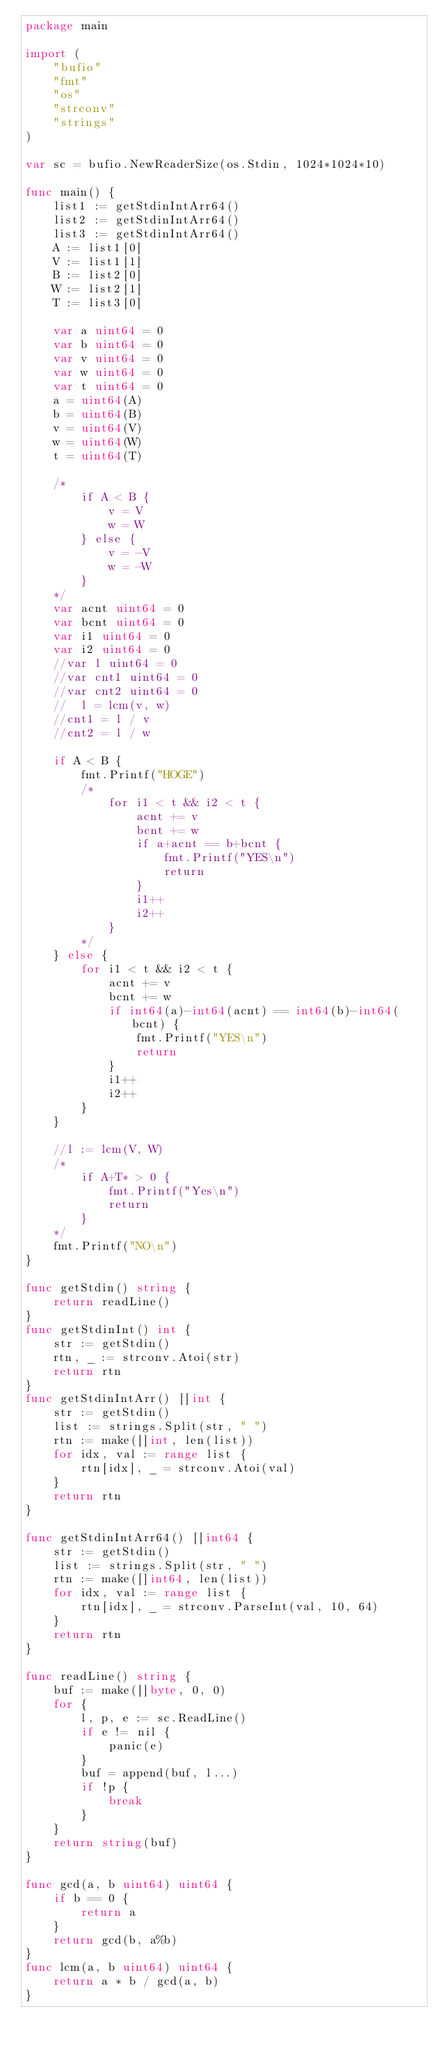Convert code to text. <code><loc_0><loc_0><loc_500><loc_500><_Go_>package main

import (
	"bufio"
	"fmt"
	"os"
	"strconv"
	"strings"
)

var sc = bufio.NewReaderSize(os.Stdin, 1024*1024*10)

func main() {
	list1 := getStdinIntArr64()
	list2 := getStdinIntArr64()
	list3 := getStdinIntArr64()
	A := list1[0]
	V := list1[1]
	B := list2[0]
	W := list2[1]
	T := list3[0]

	var a uint64 = 0
	var b uint64 = 0
	var v uint64 = 0
	var w uint64 = 0
	var t uint64 = 0
	a = uint64(A)
	b = uint64(B)
	v = uint64(V)
	w = uint64(W)
	t = uint64(T)

	/*
		if A < B {
			v = V
			w = W
		} else {
			v = -V
			w = -W
		}
	*/
	var acnt uint64 = 0
	var bcnt uint64 = 0
	var i1 uint64 = 0
	var i2 uint64 = 0
	//var l uint64 = 0
	//var cnt1 uint64 = 0
	//var cnt2 uint64 = 0
	//	l = lcm(v, w)
	//cnt1 = l / v
	//cnt2 = l / w

	if A < B {
		fmt.Printf("HOGE")
		/*
			for i1 < t && i2 < t {
				acnt += v
				bcnt += w
				if a+acnt == b+bcnt {
					fmt.Printf("YES\n")
					return
				}
				i1++
				i2++
			}
		*/
	} else {
		for i1 < t && i2 < t {
			acnt += v
			bcnt += w
			if int64(a)-int64(acnt) == int64(b)-int64(bcnt) {
				fmt.Printf("YES\n")
				return
			}
			i1++
			i2++
		}
	}

	//l := lcm(V, W)
	/*
		if A+T* > 0 {
			fmt.Printf("Yes\n")
			return
		}
	*/
	fmt.Printf("NO\n")
}

func getStdin() string {
	return readLine()
}
func getStdinInt() int {
	str := getStdin()
	rtn, _ := strconv.Atoi(str)
	return rtn
}
func getStdinIntArr() []int {
	str := getStdin()
	list := strings.Split(str, " ")
	rtn := make([]int, len(list))
	for idx, val := range list {
		rtn[idx], _ = strconv.Atoi(val)
	}
	return rtn
}

func getStdinIntArr64() []int64 {
	str := getStdin()
	list := strings.Split(str, " ")
	rtn := make([]int64, len(list))
	for idx, val := range list {
		rtn[idx], _ = strconv.ParseInt(val, 10, 64)
	}
	return rtn
}

func readLine() string {
	buf := make([]byte, 0, 0)
	for {
		l, p, e := sc.ReadLine()
		if e != nil {
			panic(e)
		}
		buf = append(buf, l...)
		if !p {
			break
		}
	}
	return string(buf)
}

func gcd(a, b uint64) uint64 {
	if b == 0 {
		return a
	}
	return gcd(b, a%b)
}
func lcm(a, b uint64) uint64 {
	return a * b / gcd(a, b)
}
</code> 